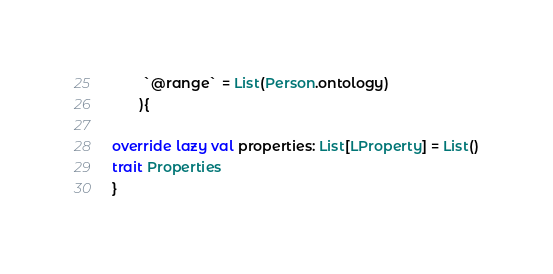Convert code to text. <code><loc_0><loc_0><loc_500><loc_500><_Scala_>        `@range` = List(Person.ontology)
       ){

override lazy val properties: List[LProperty] = List()
trait Properties 
}</code> 